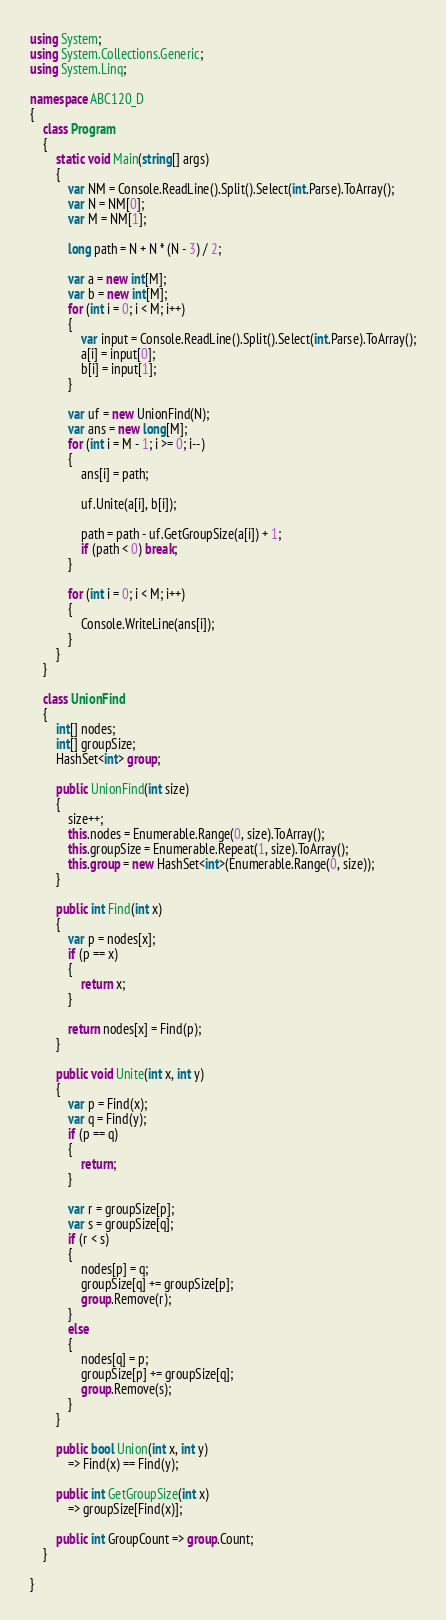Convert code to text. <code><loc_0><loc_0><loc_500><loc_500><_C#_>using System;
using System.Collections.Generic;
using System.Linq;

namespace ABC120_D
{
    class Program
    {
        static void Main(string[] args)
        {
            var NM = Console.ReadLine().Split().Select(int.Parse).ToArray();
            var N = NM[0];
            var M = NM[1];

            long path = N + N * (N - 3) / 2;

            var a = new int[M];
            var b = new int[M];
            for (int i = 0; i < M; i++)
            {
                var input = Console.ReadLine().Split().Select(int.Parse).ToArray();
                a[i] = input[0];
                b[i] = input[1];
            }

            var uf = new UnionFind(N);
            var ans = new long[M];
            for (int i = M - 1; i >= 0; i--)
            {
                ans[i] = path;

                uf.Unite(a[i], b[i]);

                path = path - uf.GetGroupSize(a[i]) + 1;
                if (path < 0) break;
            }

            for (int i = 0; i < M; i++)
            {
                Console.WriteLine(ans[i]);
            }
        }
    }

    class UnionFind
    {
        int[] nodes;
        int[] groupSize;
        HashSet<int> group;

        public UnionFind(int size)
        {
            size++;
            this.nodes = Enumerable.Range(0, size).ToArray();
            this.groupSize = Enumerable.Repeat(1, size).ToArray();
            this.group = new HashSet<int>(Enumerable.Range(0, size));
        }

        public int Find(int x)
        {
            var p = nodes[x];
            if (p == x)
            {
                return x;
            }

            return nodes[x] = Find(p);
        }

        public void Unite(int x, int y)
        {
            var p = Find(x);
            var q = Find(y);
            if (p == q)
            {
                return;
            }

            var r = groupSize[p];
            var s = groupSize[q];
            if (r < s)
            {
                nodes[p] = q;
                groupSize[q] += groupSize[p];
                group.Remove(r);
            }
            else
            {
                nodes[q] = p;
                groupSize[p] += groupSize[q];
                group.Remove(s);
            }
        }

        public bool Union(int x, int y)
            => Find(x) == Find(y);

        public int GetGroupSize(int x)
            => groupSize[Find(x)];

        public int GroupCount => group.Count;
    }

}
</code> 